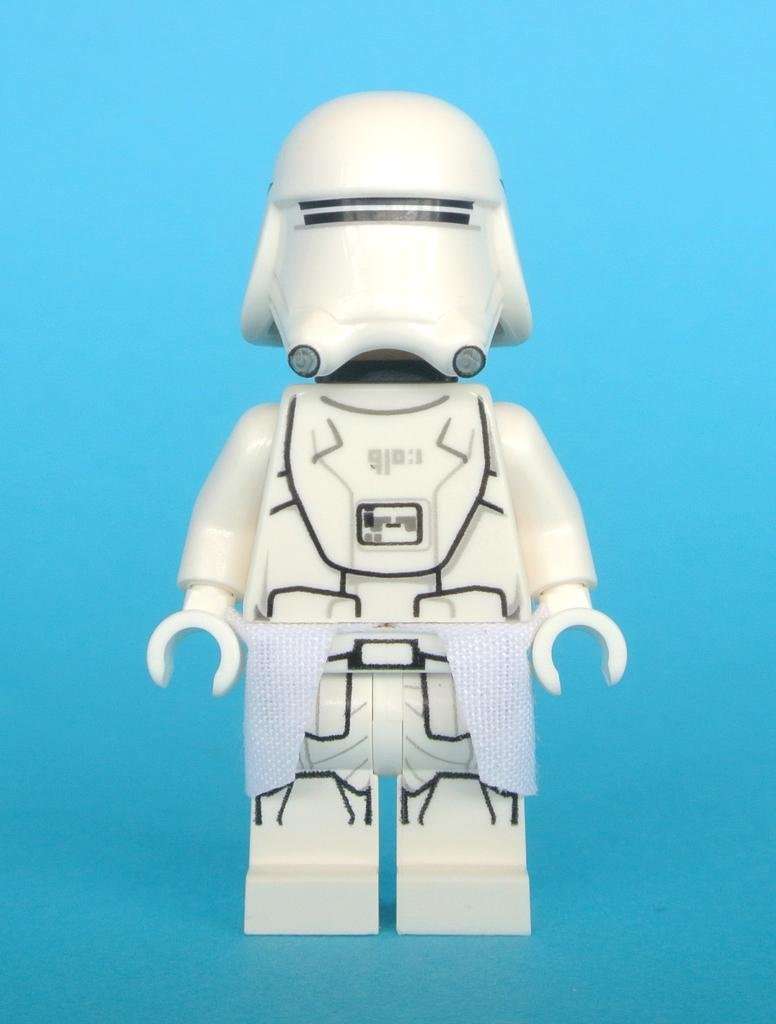What type of material is the doll made of in the image? The doll is made up of plastic in the image. What color is the doll in the image? The doll is in white color. What can be seen in the background of the image? The background of the image is blue in color. How many lizards are crawling on the doll in the image? There are no lizards present in the image; it only features a plastic doll. What type of rifle is visible in the image? There is no rifle present in the image. 